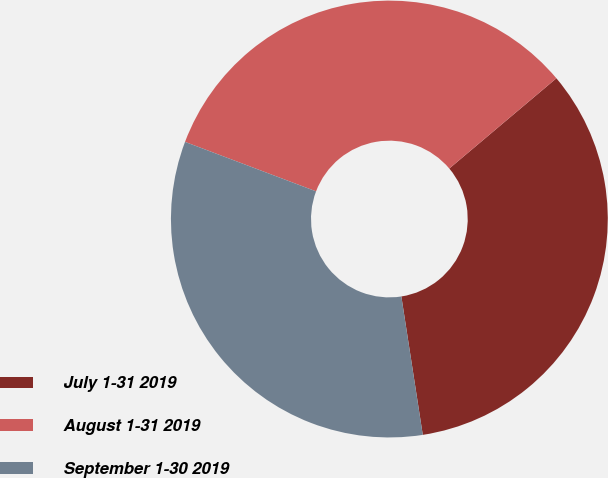<chart> <loc_0><loc_0><loc_500><loc_500><pie_chart><fcel>July 1-31 2019<fcel>August 1-31 2019<fcel>September 1-30 2019<nl><fcel>33.7%<fcel>33.11%<fcel>33.19%<nl></chart> 